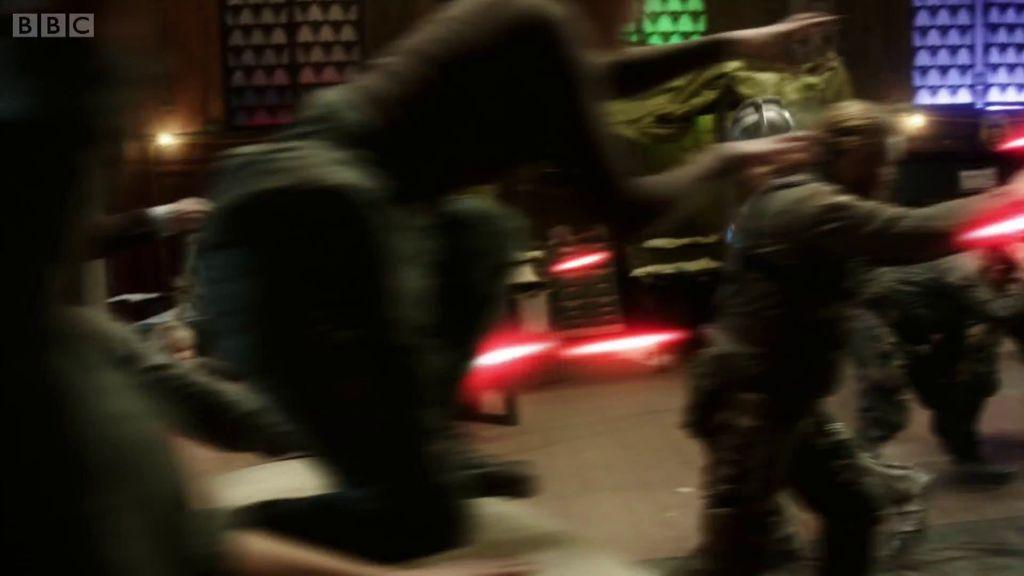Who or what can be seen in the image? There are people in the image. What else is visible in the image besides the people? There are lights and text in the top left of the image. What can be seen in the background of the image? There is a wall in the background of the image. Are there any architectural features visible in the image? Yes, there are windows at the top of the image. What type of stone is being used to construct the government building in the image? There is no government building or stone construction visible in the image. Can you see any sails in the image? There are no sails present in the image. 